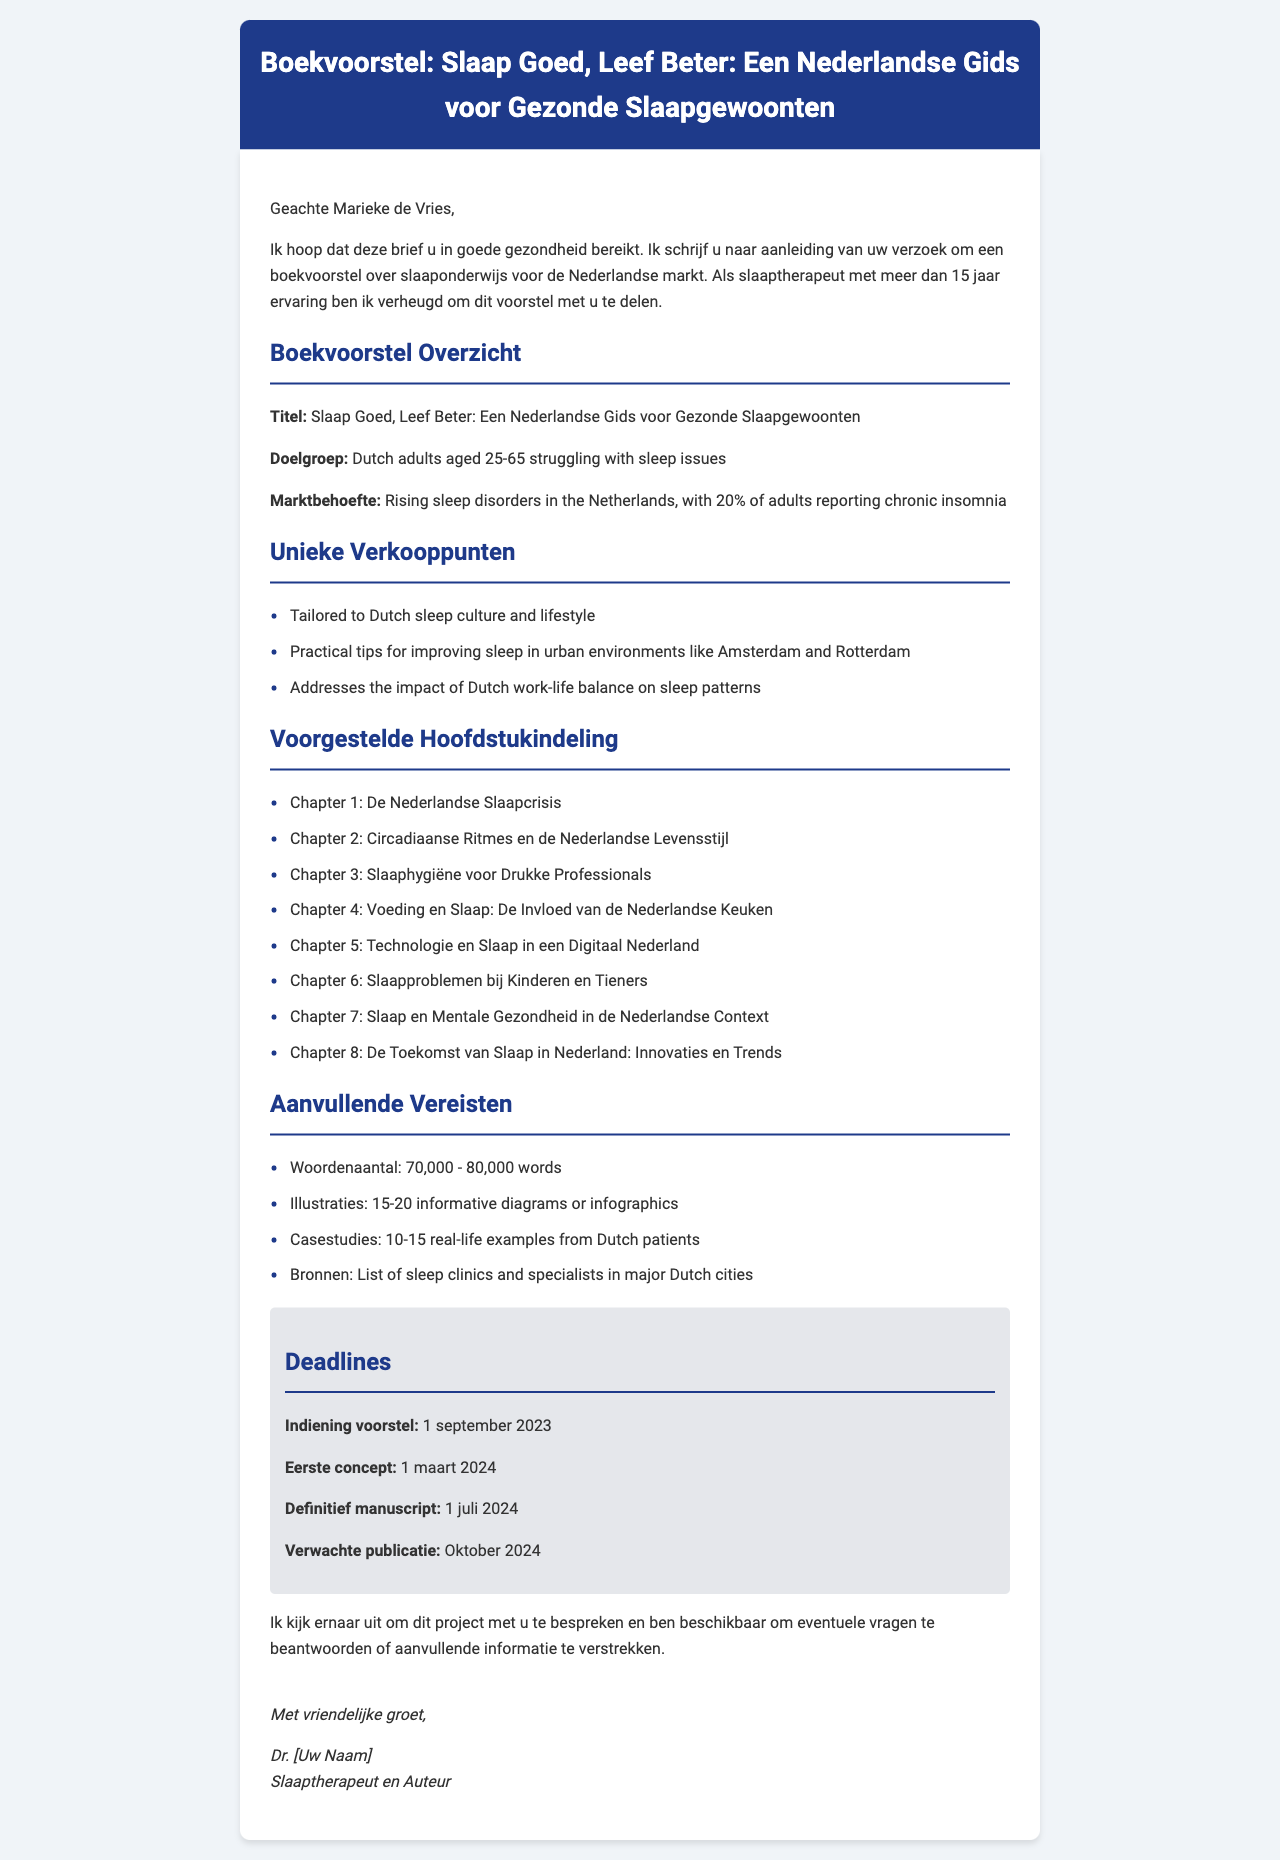What is the working title of the book proposal? The working title can be found in the book proposal section of the document, which is "Slaap Goed, Leef Beter: Een Nederlandse Gids voor Gezonde Slaapgewoonten."
Answer: Slaap Goed, Leef Beter: Een Nederlandse Gids voor Gezonde Slaapgewoonten Who is the contact person at the publishing house? The contact person is mentioned in the publisher's section of the document as Marieke de Vries.
Answer: Marieke de Vries What is the deadline for the first draft submission? The deadline for the first draft is specified in the deadlines section of the document as "1 maart 2024."
Answer: 1 maart 2024 What are the unique selling points of the book? The unique selling points are listed in a bullet format under the unique selling points section of the document.
Answer: Tailored to Dutch sleep culture and lifestyle, Practical tips for improving sleep in urban environments like Amsterdam and Rotterdam, Addresses the impact of Dutch work-life balance on sleep patterns What is the target audience for the book? The target audience is directly stated in the book proposal section as "Dutch adults aged 25-65 struggling with sleep issues."
Answer: Dutch adults aged 25-65 struggling with sleep issues How many words should the final manuscript contain? The word count requirement is found in the additional requirements section, specifying the range for the final manuscript.
Answer: 70,000 - 80,000 words What is one promotional opportunity mentioned in the document? Promotional opportunities are highlighted in a specific section of the document, indicating various marketing strategies for the book.
Answer: Book launch event at SLEEP 2024 conference in Rotterdam Which chapter addresses sleep issues in children and teenagers? The chapter addressing this topic is listed in the proposed outline of chapters in the document.
Answer: Chapter 6: Slaapproblemen bij Kinderen en Tieners 